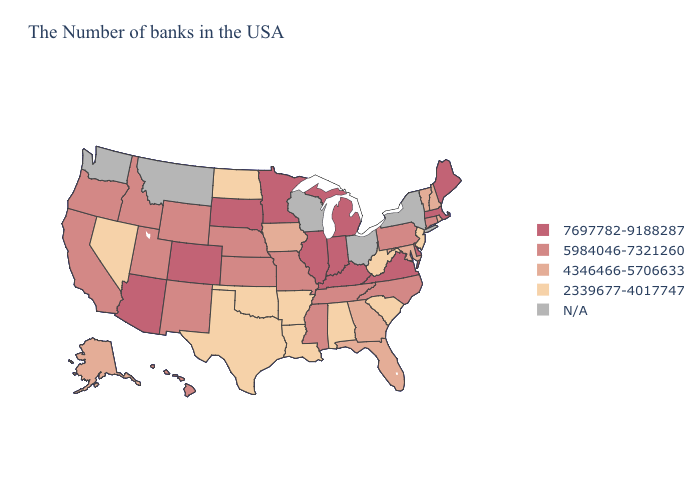Which states have the lowest value in the USA?
Quick response, please. New Jersey, South Carolina, West Virginia, Alabama, Louisiana, Arkansas, Oklahoma, Texas, North Dakota, Nevada. Name the states that have a value in the range 4346466-5706633?
Be succinct. Rhode Island, New Hampshire, Vermont, Maryland, Florida, Georgia, Iowa, Alaska. Name the states that have a value in the range 2339677-4017747?
Answer briefly. New Jersey, South Carolina, West Virginia, Alabama, Louisiana, Arkansas, Oklahoma, Texas, North Dakota, Nevada. Does North Dakota have the highest value in the USA?
Concise answer only. No. How many symbols are there in the legend?
Give a very brief answer. 5. What is the value of Texas?
Answer briefly. 2339677-4017747. What is the value of Ohio?
Answer briefly. N/A. Name the states that have a value in the range N/A?
Write a very short answer. New York, Ohio, Wisconsin, Montana, Washington. Does North Dakota have the lowest value in the MidWest?
Answer briefly. Yes. What is the lowest value in the South?
Give a very brief answer. 2339677-4017747. Name the states that have a value in the range 2339677-4017747?
Concise answer only. New Jersey, South Carolina, West Virginia, Alabama, Louisiana, Arkansas, Oklahoma, Texas, North Dakota, Nevada. Does Massachusetts have the highest value in the USA?
Be succinct. Yes. Is the legend a continuous bar?
Short answer required. No. What is the highest value in the USA?
Concise answer only. 7697782-9188287. Which states have the lowest value in the Northeast?
Quick response, please. New Jersey. 